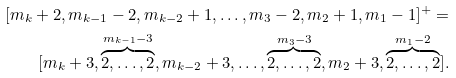Convert formula to latex. <formula><loc_0><loc_0><loc_500><loc_500>[ m _ { k } + 2 , m _ { k - 1 } - 2 , m _ { k - 2 } + 1 , \dots , m _ { 3 } - 2 , m _ { 2 } + 1 , m _ { 1 } - 1 ] ^ { + } = \\ [ m _ { k } + 3 , \overbrace { 2 , \dots , 2 } ^ { m _ { k - 1 } - 3 } , m _ { k - 2 } + 3 , \dots , \overbrace { 2 , \dots , 2 } ^ { m _ { 3 } - 3 } , m _ { 2 } + 3 , \overbrace { 2 , \dots , 2 } ^ { m _ { 1 } - 2 } ] .</formula> 